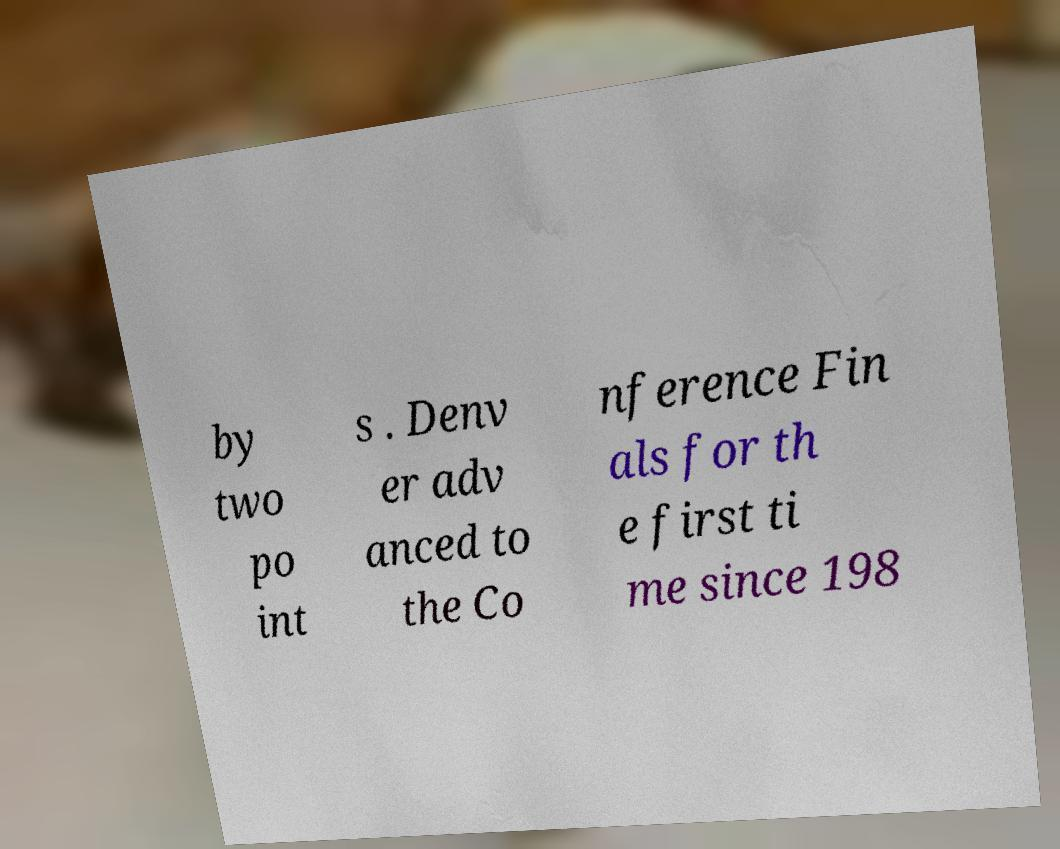Could you assist in decoding the text presented in this image and type it out clearly? by two po int s . Denv er adv anced to the Co nference Fin als for th e first ti me since 198 